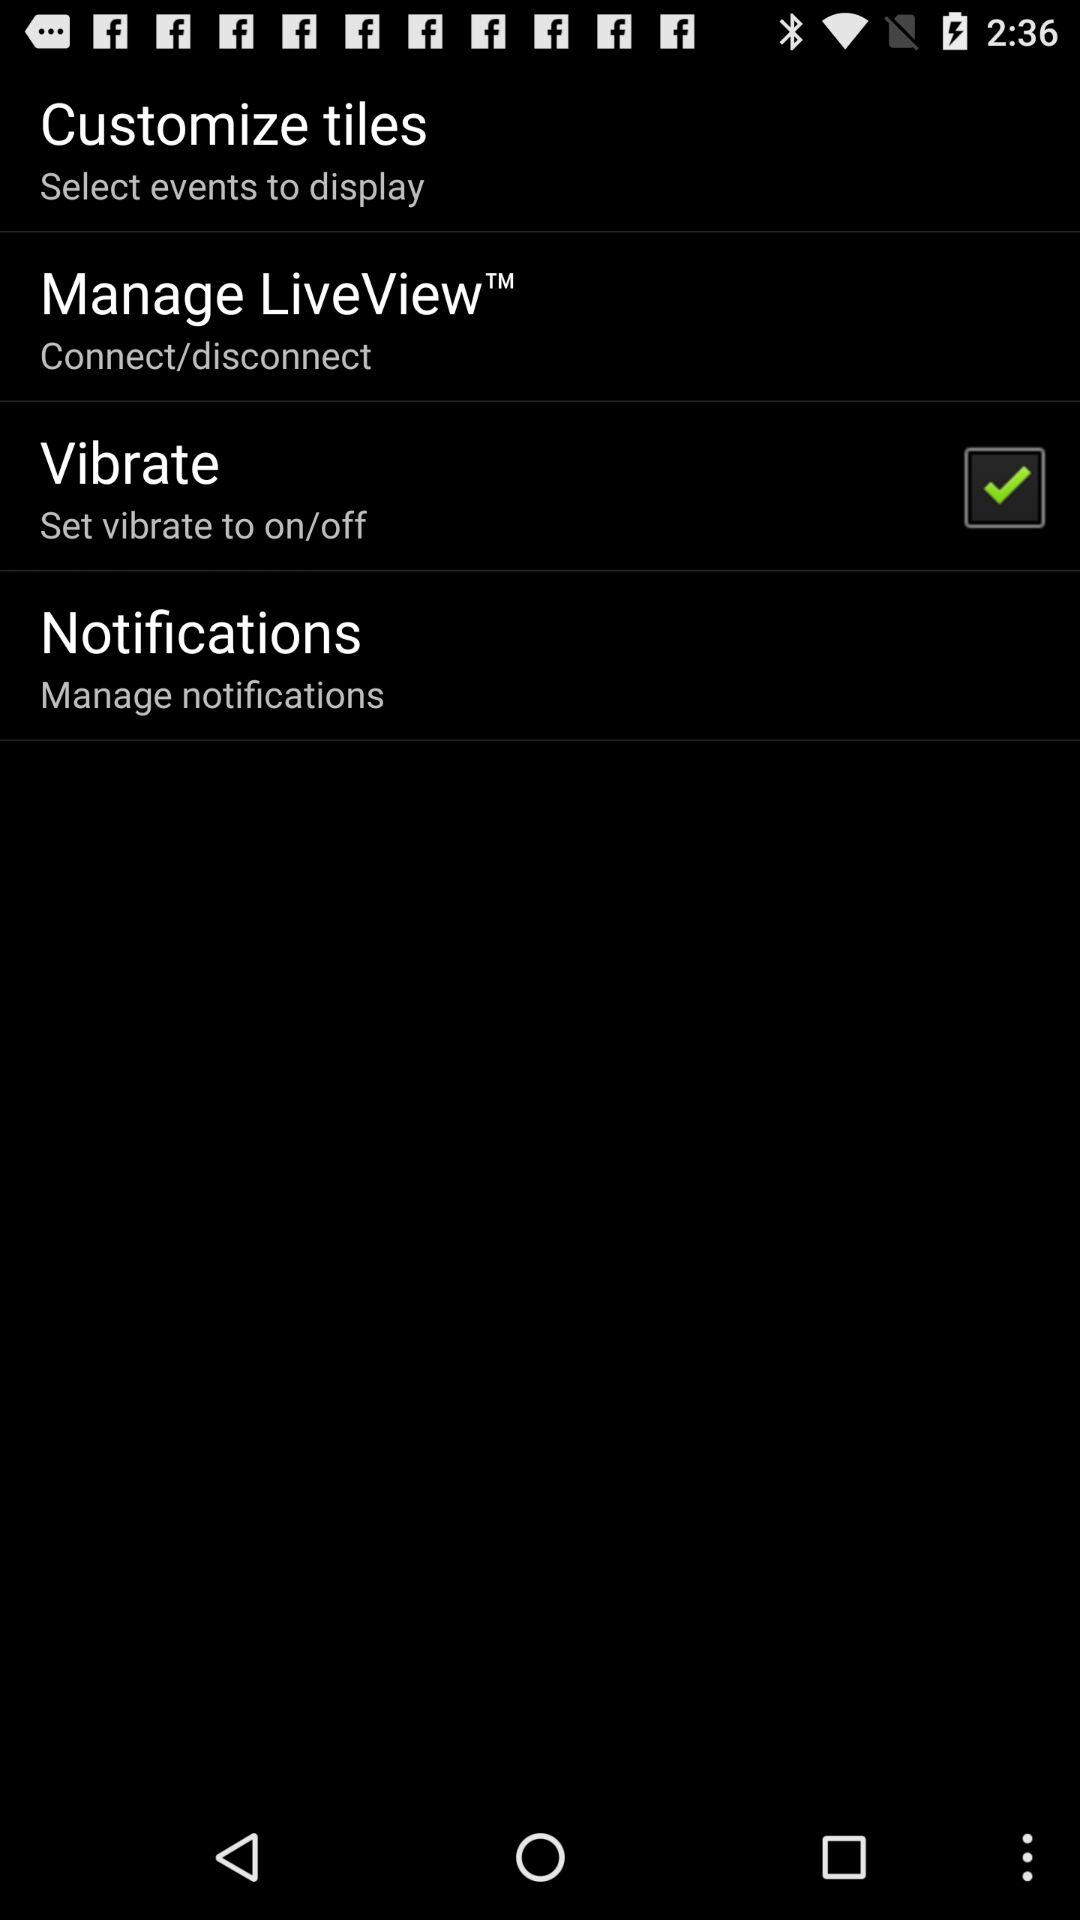How many items have a text label?
Answer the question using a single word or phrase. 4 